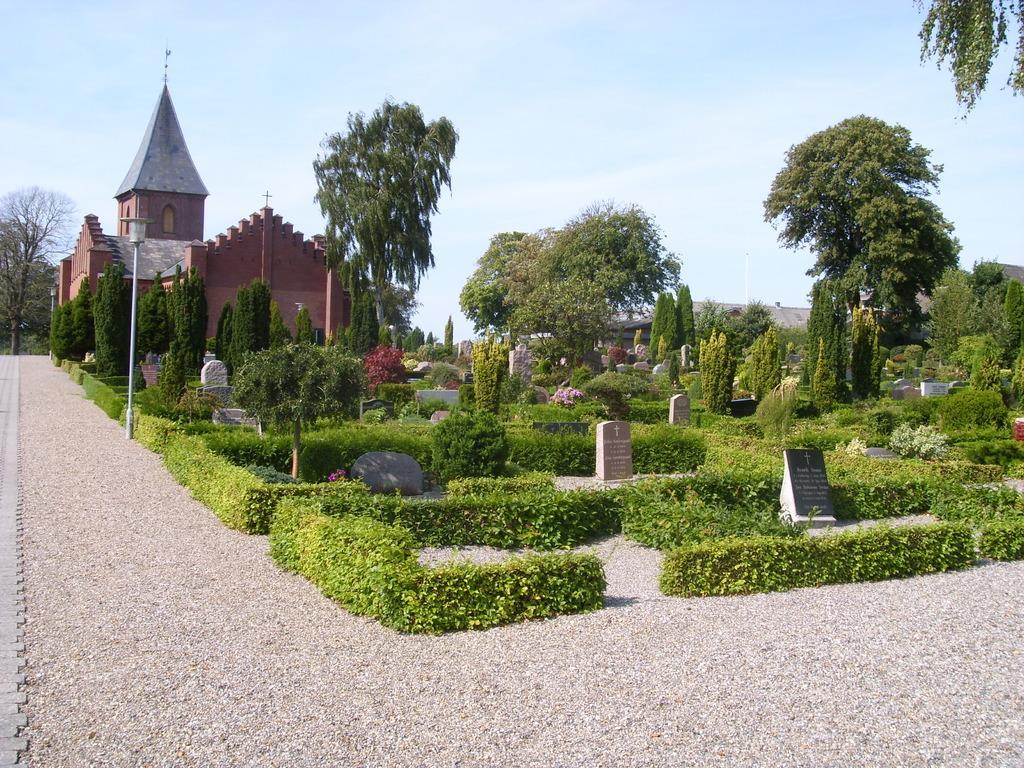Please provide a concise description of this image. At the bottom of the image there is ground. There are bushes and small plants. In between them there are graves. And also there are trees in the image. Behind them there is a building with roofs, walls and pillars. At the top of the image there is sky. 